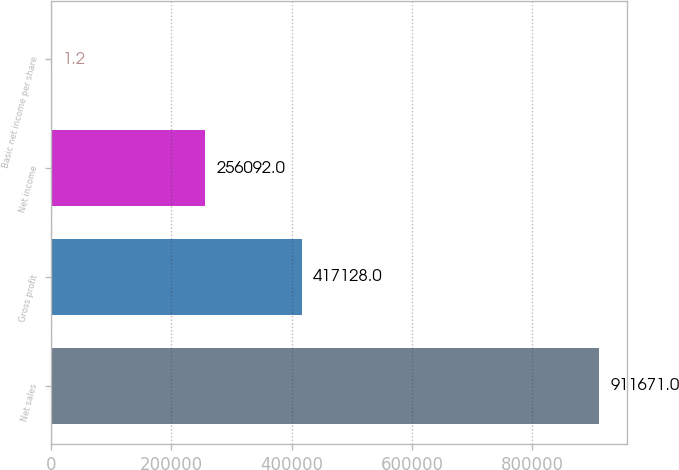Convert chart. <chart><loc_0><loc_0><loc_500><loc_500><bar_chart><fcel>Net sales<fcel>Gross profit<fcel>Net income<fcel>Basic net income per share<nl><fcel>911671<fcel>417128<fcel>256092<fcel>1.2<nl></chart> 